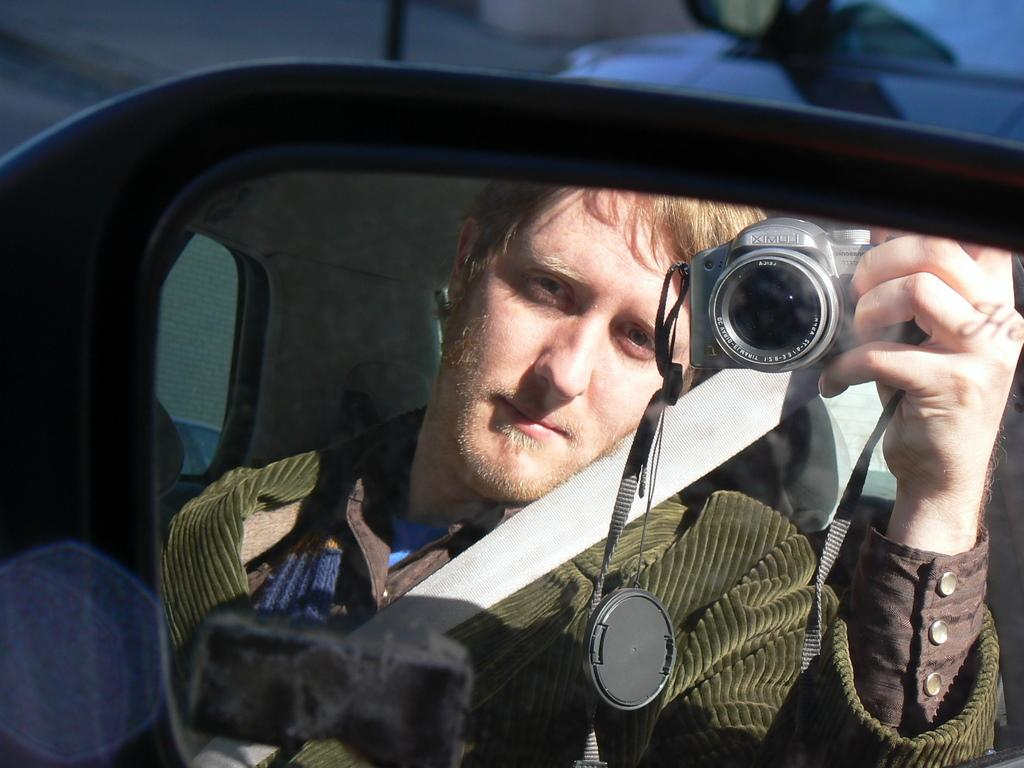What is the main subject of the image? There is a person in the image. What is the person doing in the image? The person is sitting in a vehicle. What object is the person holding in their hand? The person is holding a camera in their hand. Can you describe the background of the image? The background of the image is blurred. What type of cent can be seen in the image? There is no cent present in the image. What attraction is the person visiting in the image? The image does not provide information about any attractions the person might be visiting. 